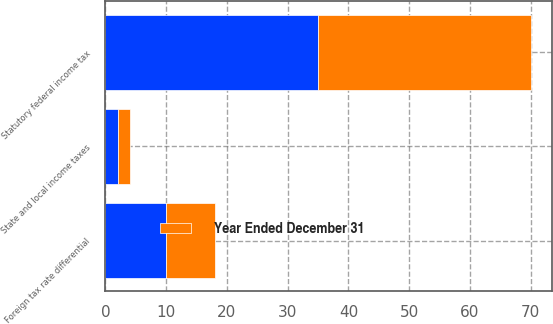Convert chart. <chart><loc_0><loc_0><loc_500><loc_500><stacked_bar_chart><ecel><fcel>Statutory federal income tax<fcel>State and local income taxes<fcel>Foreign tax rate differential<nl><fcel>nan<fcel>35<fcel>2<fcel>10<nl><fcel>Year Ended December 31<fcel>35<fcel>2<fcel>8<nl></chart> 